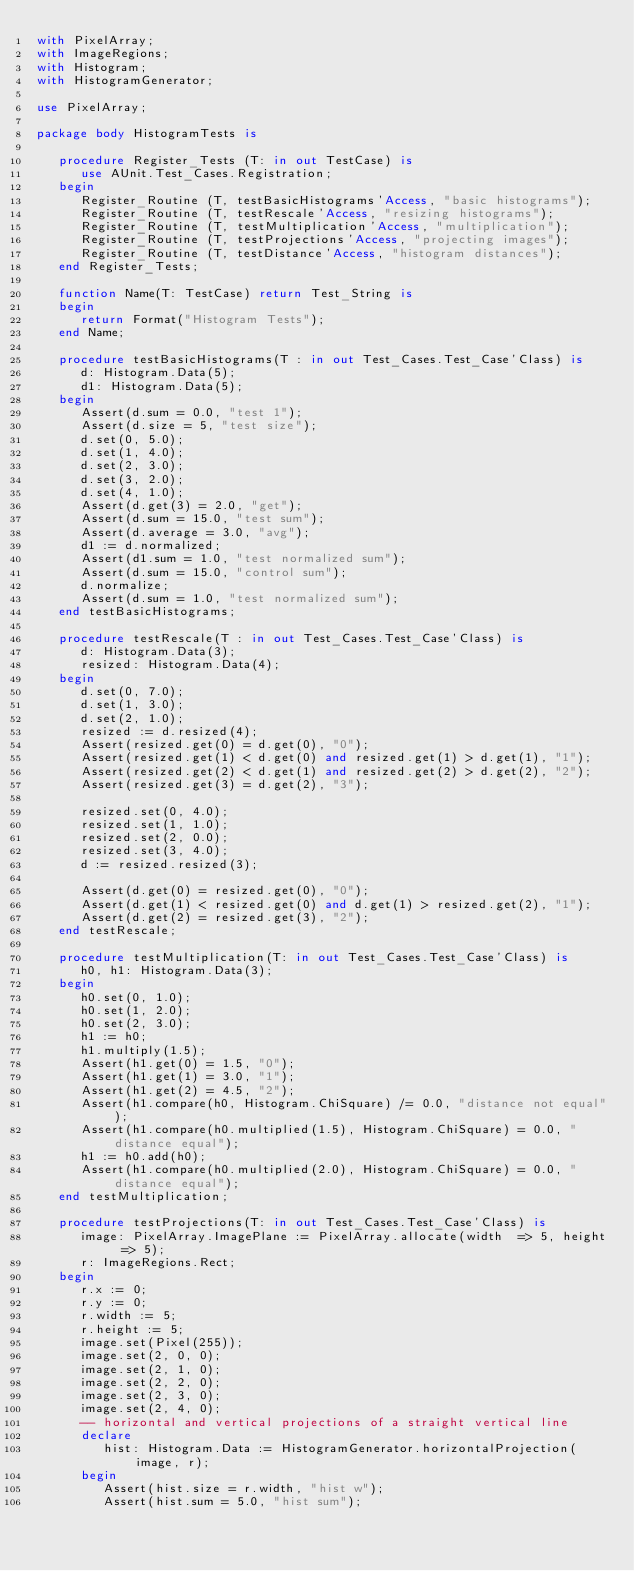Convert code to text. <code><loc_0><loc_0><loc_500><loc_500><_Ada_>with PixelArray;
with ImageRegions;
with Histogram;
with HistogramGenerator;

use PixelArray;

package body HistogramTests is

   procedure Register_Tests (T: in out TestCase) is
      use AUnit.Test_Cases.Registration;
   begin
      Register_Routine (T, testBasicHistograms'Access, "basic histograms");
      Register_Routine (T, testRescale'Access, "resizing histograms");
      Register_Routine (T, testMultiplication'Access, "multiplication");
      Register_Routine (T, testProjections'Access, "projecting images");
      Register_Routine (T, testDistance'Access, "histogram distances");
   end Register_Tests;

   function Name(T: TestCase) return Test_String is
   begin
      return Format("Histogram Tests");
   end Name;

   procedure testBasicHistograms(T : in out Test_Cases.Test_Case'Class) is
      d: Histogram.Data(5);
      d1: Histogram.Data(5);
   begin
      Assert(d.sum = 0.0, "test 1");
      Assert(d.size = 5, "test size");
      d.set(0, 5.0);
      d.set(1, 4.0);
      d.set(2, 3.0);
      d.set(3, 2.0);
      d.set(4, 1.0);
      Assert(d.get(3) = 2.0, "get");
      Assert(d.sum = 15.0, "test sum");
      Assert(d.average = 3.0, "avg");
      d1 := d.normalized;
      Assert(d1.sum = 1.0, "test normalized sum");
      Assert(d.sum = 15.0, "control sum");
      d.normalize;
      Assert(d.sum = 1.0, "test normalized sum");
   end testBasicHistograms;

   procedure testRescale(T : in out Test_Cases.Test_Case'Class) is
      d: Histogram.Data(3);
      resized: Histogram.Data(4);
   begin
      d.set(0, 7.0);
      d.set(1, 3.0);
      d.set(2, 1.0);
      resized := d.resized(4);
      Assert(resized.get(0) = d.get(0), "0");
      Assert(resized.get(1) < d.get(0) and resized.get(1) > d.get(1), "1");
      Assert(resized.get(2) < d.get(1) and resized.get(2) > d.get(2), "2");
      Assert(resized.get(3) = d.get(2), "3");

      resized.set(0, 4.0);
      resized.set(1, 1.0);
      resized.set(2, 0.0);
      resized.set(3, 4.0);
      d := resized.resized(3);

      Assert(d.get(0) = resized.get(0), "0");
      Assert(d.get(1) < resized.get(0) and d.get(1) > resized.get(2), "1");
      Assert(d.get(2) = resized.get(3), "2");
   end testRescale;

   procedure testMultiplication(T: in out Test_Cases.Test_Case'Class) is
      h0, h1: Histogram.Data(3);
   begin
      h0.set(0, 1.0);
      h0.set(1, 2.0);
      h0.set(2, 3.0);
      h1 := h0;
      h1.multiply(1.5);
      Assert(h1.get(0) = 1.5, "0");
      Assert(h1.get(1) = 3.0, "1");
      Assert(h1.get(2) = 4.5, "2");
      Assert(h1.compare(h0, Histogram.ChiSquare) /= 0.0, "distance not equal");
      Assert(h1.compare(h0.multiplied(1.5), Histogram.ChiSquare) = 0.0, "distance equal");
      h1 := h0.add(h0);
      Assert(h1.compare(h0.multiplied(2.0), Histogram.ChiSquare) = 0.0, "distance equal");
   end testMultiplication;

   procedure testProjections(T: in out Test_Cases.Test_Case'Class) is
      image: PixelArray.ImagePlane := PixelArray.allocate(width  => 5, height => 5);
      r: ImageRegions.Rect;
   begin
      r.x := 0;
      r.y := 0;
      r.width := 5;
      r.height := 5;
      image.set(Pixel(255));
      image.set(2, 0, 0);
      image.set(2, 1, 0);
      image.set(2, 2, 0);
      image.set(2, 3, 0);
      image.set(2, 4, 0);
      -- horizontal and vertical projections of a straight vertical line
      declare
         hist: Histogram.Data := HistogramGenerator.horizontalProjection(image, r);
      begin
         Assert(hist.size = r.width, "hist w");
         Assert(hist.sum = 5.0, "hist sum");</code> 